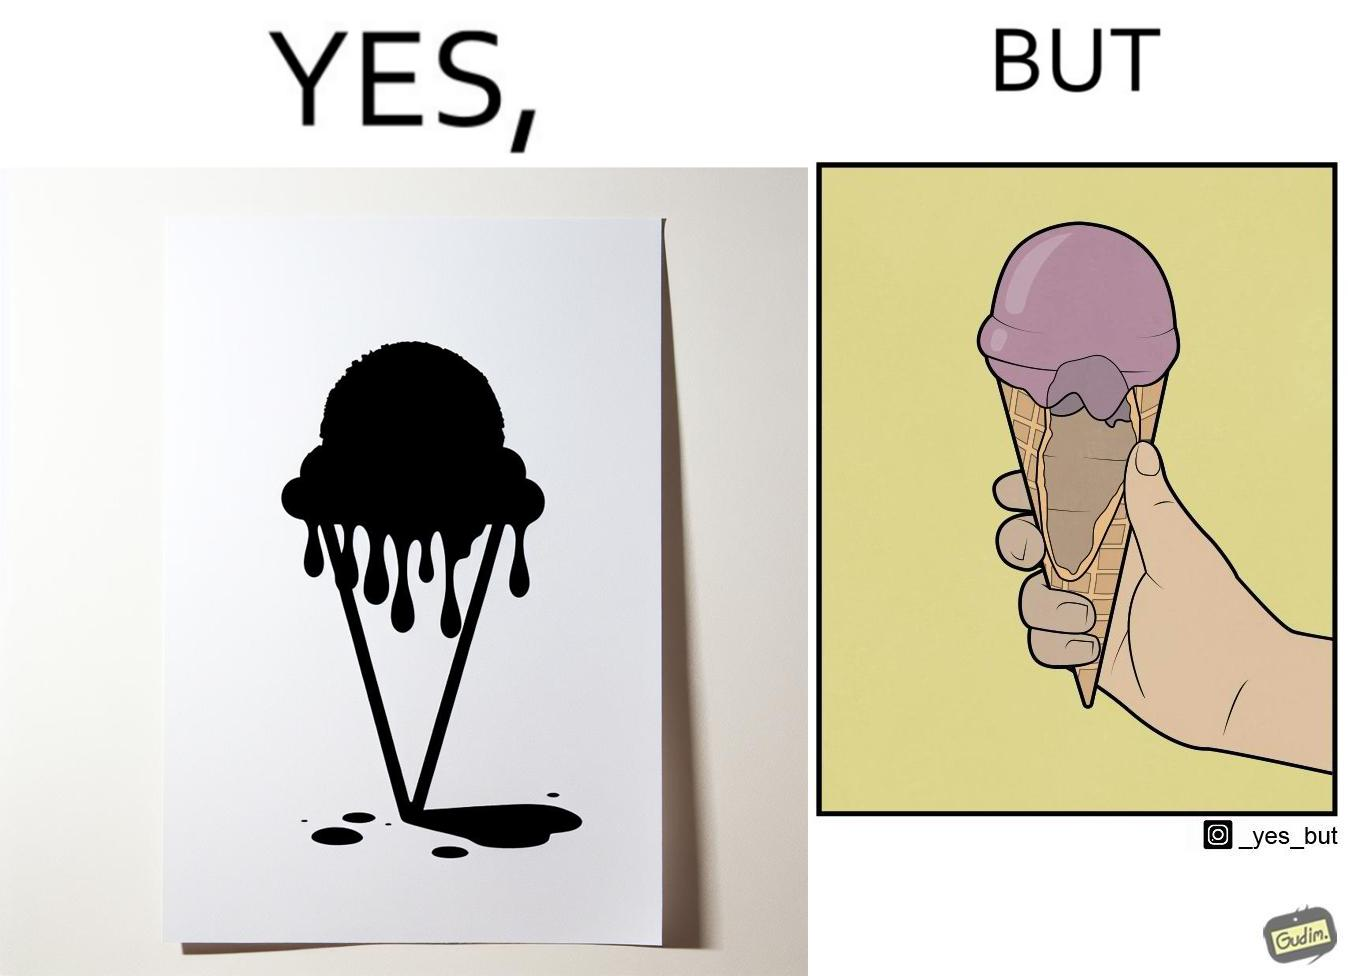Would you classify this image as satirical? Yes, this image is satirical. 